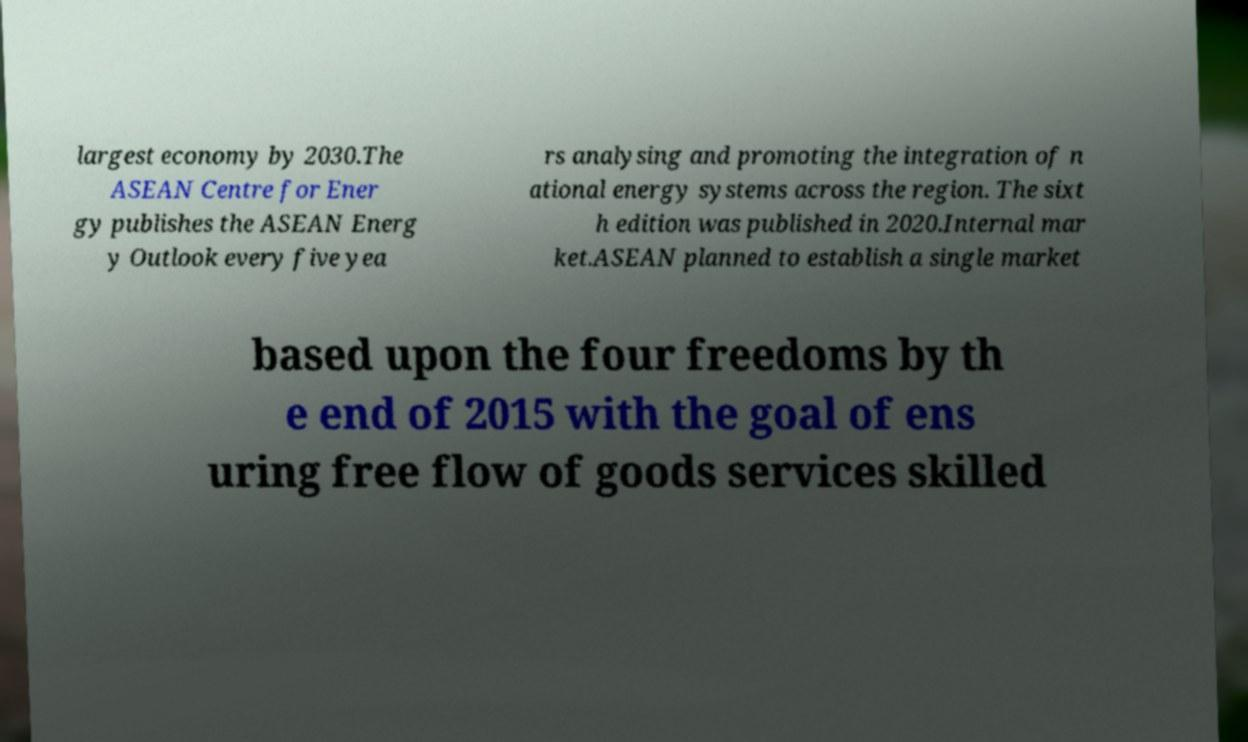Could you extract and type out the text from this image? largest economy by 2030.The ASEAN Centre for Ener gy publishes the ASEAN Energ y Outlook every five yea rs analysing and promoting the integration of n ational energy systems across the region. The sixt h edition was published in 2020.Internal mar ket.ASEAN planned to establish a single market based upon the four freedoms by th e end of 2015 with the goal of ens uring free flow of goods services skilled 